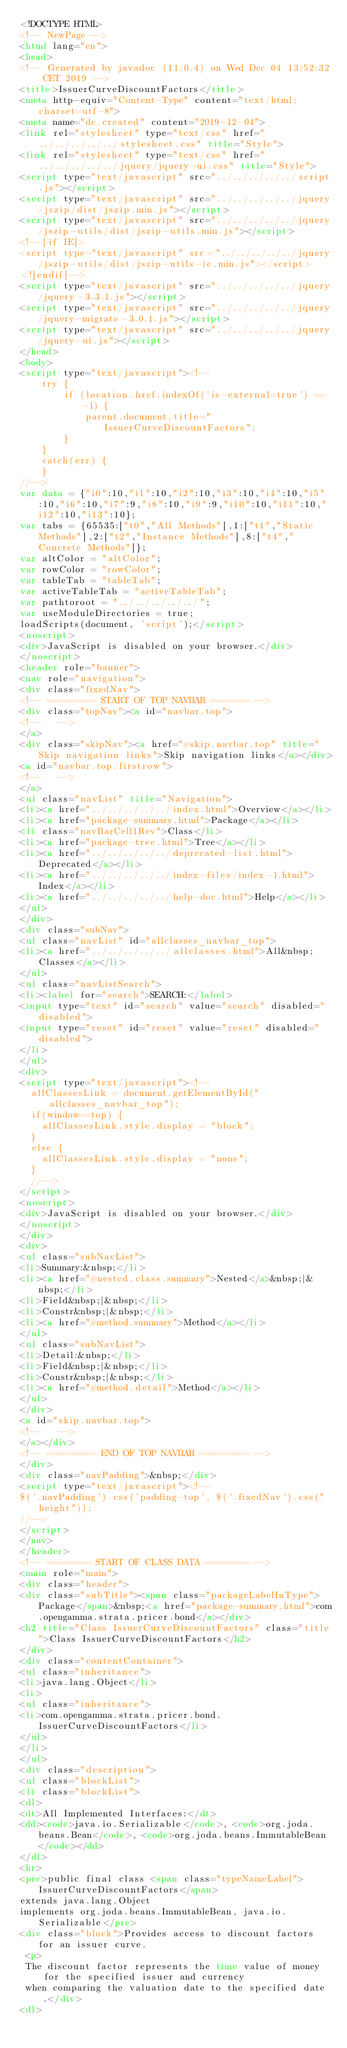<code> <loc_0><loc_0><loc_500><loc_500><_HTML_><!DOCTYPE HTML>
<!-- NewPage -->
<html lang="en">
<head>
<!-- Generated by javadoc (11.0.4) on Wed Dec 04 13:52:32 CET 2019 -->
<title>IssuerCurveDiscountFactors</title>
<meta http-equiv="Content-Type" content="text/html; charset=utf-8">
<meta name="dc.created" content="2019-12-04">
<link rel="stylesheet" type="text/css" href="../../../../../stylesheet.css" title="Style">
<link rel="stylesheet" type="text/css" href="../../../../../jquery/jquery-ui.css" title="Style">
<script type="text/javascript" src="../../../../../script.js"></script>
<script type="text/javascript" src="../../../../../jquery/jszip/dist/jszip.min.js"></script>
<script type="text/javascript" src="../../../../../jquery/jszip-utils/dist/jszip-utils.min.js"></script>
<!--[if IE]>
<script type="text/javascript" src="../../../../../jquery/jszip-utils/dist/jszip-utils-ie.min.js"></script>
<![endif]-->
<script type="text/javascript" src="../../../../../jquery/jquery-3.3.1.js"></script>
<script type="text/javascript" src="../../../../../jquery/jquery-migrate-3.0.1.js"></script>
<script type="text/javascript" src="../../../../../jquery/jquery-ui.js"></script>
</head>
<body>
<script type="text/javascript"><!--
    try {
        if (location.href.indexOf('is-external=true') == -1) {
            parent.document.title="IssuerCurveDiscountFactors";
        }
    }
    catch(err) {
    }
//-->
var data = {"i0":10,"i1":10,"i2":10,"i3":10,"i4":10,"i5":10,"i6":10,"i7":9,"i8":10,"i9":9,"i10":10,"i11":10,"i12":10,"i13":10};
var tabs = {65535:["t0","All Methods"],1:["t1","Static Methods"],2:["t2","Instance Methods"],8:["t4","Concrete Methods"]};
var altColor = "altColor";
var rowColor = "rowColor";
var tableTab = "tableTab";
var activeTableTab = "activeTableTab";
var pathtoroot = "../../../../../";
var useModuleDirectories = true;
loadScripts(document, 'script');</script>
<noscript>
<div>JavaScript is disabled on your browser.</div>
</noscript>
<header role="banner">
<nav role="navigation">
<div class="fixedNav">
<!-- ========= START OF TOP NAVBAR ======= -->
<div class="topNav"><a id="navbar.top">
<!--   -->
</a>
<div class="skipNav"><a href="#skip.navbar.top" title="Skip navigation links">Skip navigation links</a></div>
<a id="navbar.top.firstrow">
<!--   -->
</a>
<ul class="navList" title="Navigation">
<li><a href="../../../../../index.html">Overview</a></li>
<li><a href="package-summary.html">Package</a></li>
<li class="navBarCell1Rev">Class</li>
<li><a href="package-tree.html">Tree</a></li>
<li><a href="../../../../../deprecated-list.html">Deprecated</a></li>
<li><a href="../../../../../index-files/index-1.html">Index</a></li>
<li><a href="../../../../../help-doc.html">Help</a></li>
</ul>
</div>
<div class="subNav">
<ul class="navList" id="allclasses_navbar_top">
<li><a href="../../../../../allclasses.html">All&nbsp;Classes</a></li>
</ul>
<ul class="navListSearch">
<li><label for="search">SEARCH:</label>
<input type="text" id="search" value="search" disabled="disabled">
<input type="reset" id="reset" value="reset" disabled="disabled">
</li>
</ul>
<div>
<script type="text/javascript"><!--
  allClassesLink = document.getElementById("allclasses_navbar_top");
  if(window==top) {
    allClassesLink.style.display = "block";
  }
  else {
    allClassesLink.style.display = "none";
  }
  //-->
</script>
<noscript>
<div>JavaScript is disabled on your browser.</div>
</noscript>
</div>
<div>
<ul class="subNavList">
<li>Summary:&nbsp;</li>
<li><a href="#nested.class.summary">Nested</a>&nbsp;|&nbsp;</li>
<li>Field&nbsp;|&nbsp;</li>
<li>Constr&nbsp;|&nbsp;</li>
<li><a href="#method.summary">Method</a></li>
</ul>
<ul class="subNavList">
<li>Detail:&nbsp;</li>
<li>Field&nbsp;|&nbsp;</li>
<li>Constr&nbsp;|&nbsp;</li>
<li><a href="#method.detail">Method</a></li>
</ul>
</div>
<a id="skip.navbar.top">
<!--   -->
</a></div>
<!-- ========= END OF TOP NAVBAR ========= -->
</div>
<div class="navPadding">&nbsp;</div>
<script type="text/javascript"><!--
$('.navPadding').css('padding-top', $('.fixedNav').css("height"));
//-->
</script>
</nav>
</header>
<!-- ======== START OF CLASS DATA ======== -->
<main role="main">
<div class="header">
<div class="subTitle"><span class="packageLabelInType">Package</span>&nbsp;<a href="package-summary.html">com.opengamma.strata.pricer.bond</a></div>
<h2 title="Class IssuerCurveDiscountFactors" class="title">Class IssuerCurveDiscountFactors</h2>
</div>
<div class="contentContainer">
<ul class="inheritance">
<li>java.lang.Object</li>
<li>
<ul class="inheritance">
<li>com.opengamma.strata.pricer.bond.IssuerCurveDiscountFactors</li>
</ul>
</li>
</ul>
<div class="description">
<ul class="blockList">
<li class="blockList">
<dl>
<dt>All Implemented Interfaces:</dt>
<dd><code>java.io.Serializable</code>, <code>org.joda.beans.Bean</code>, <code>org.joda.beans.ImmutableBean</code></dd>
</dl>
<hr>
<pre>public final class <span class="typeNameLabel">IssuerCurveDiscountFactors</span>
extends java.lang.Object
implements org.joda.beans.ImmutableBean, java.io.Serializable</pre>
<div class="block">Provides access to discount factors for an issuer curve.
 <p>
 The discount factor represents the time value of money for the specified issuer and currency
 when comparing the valuation date to the specified date.</div>
<dl></code> 